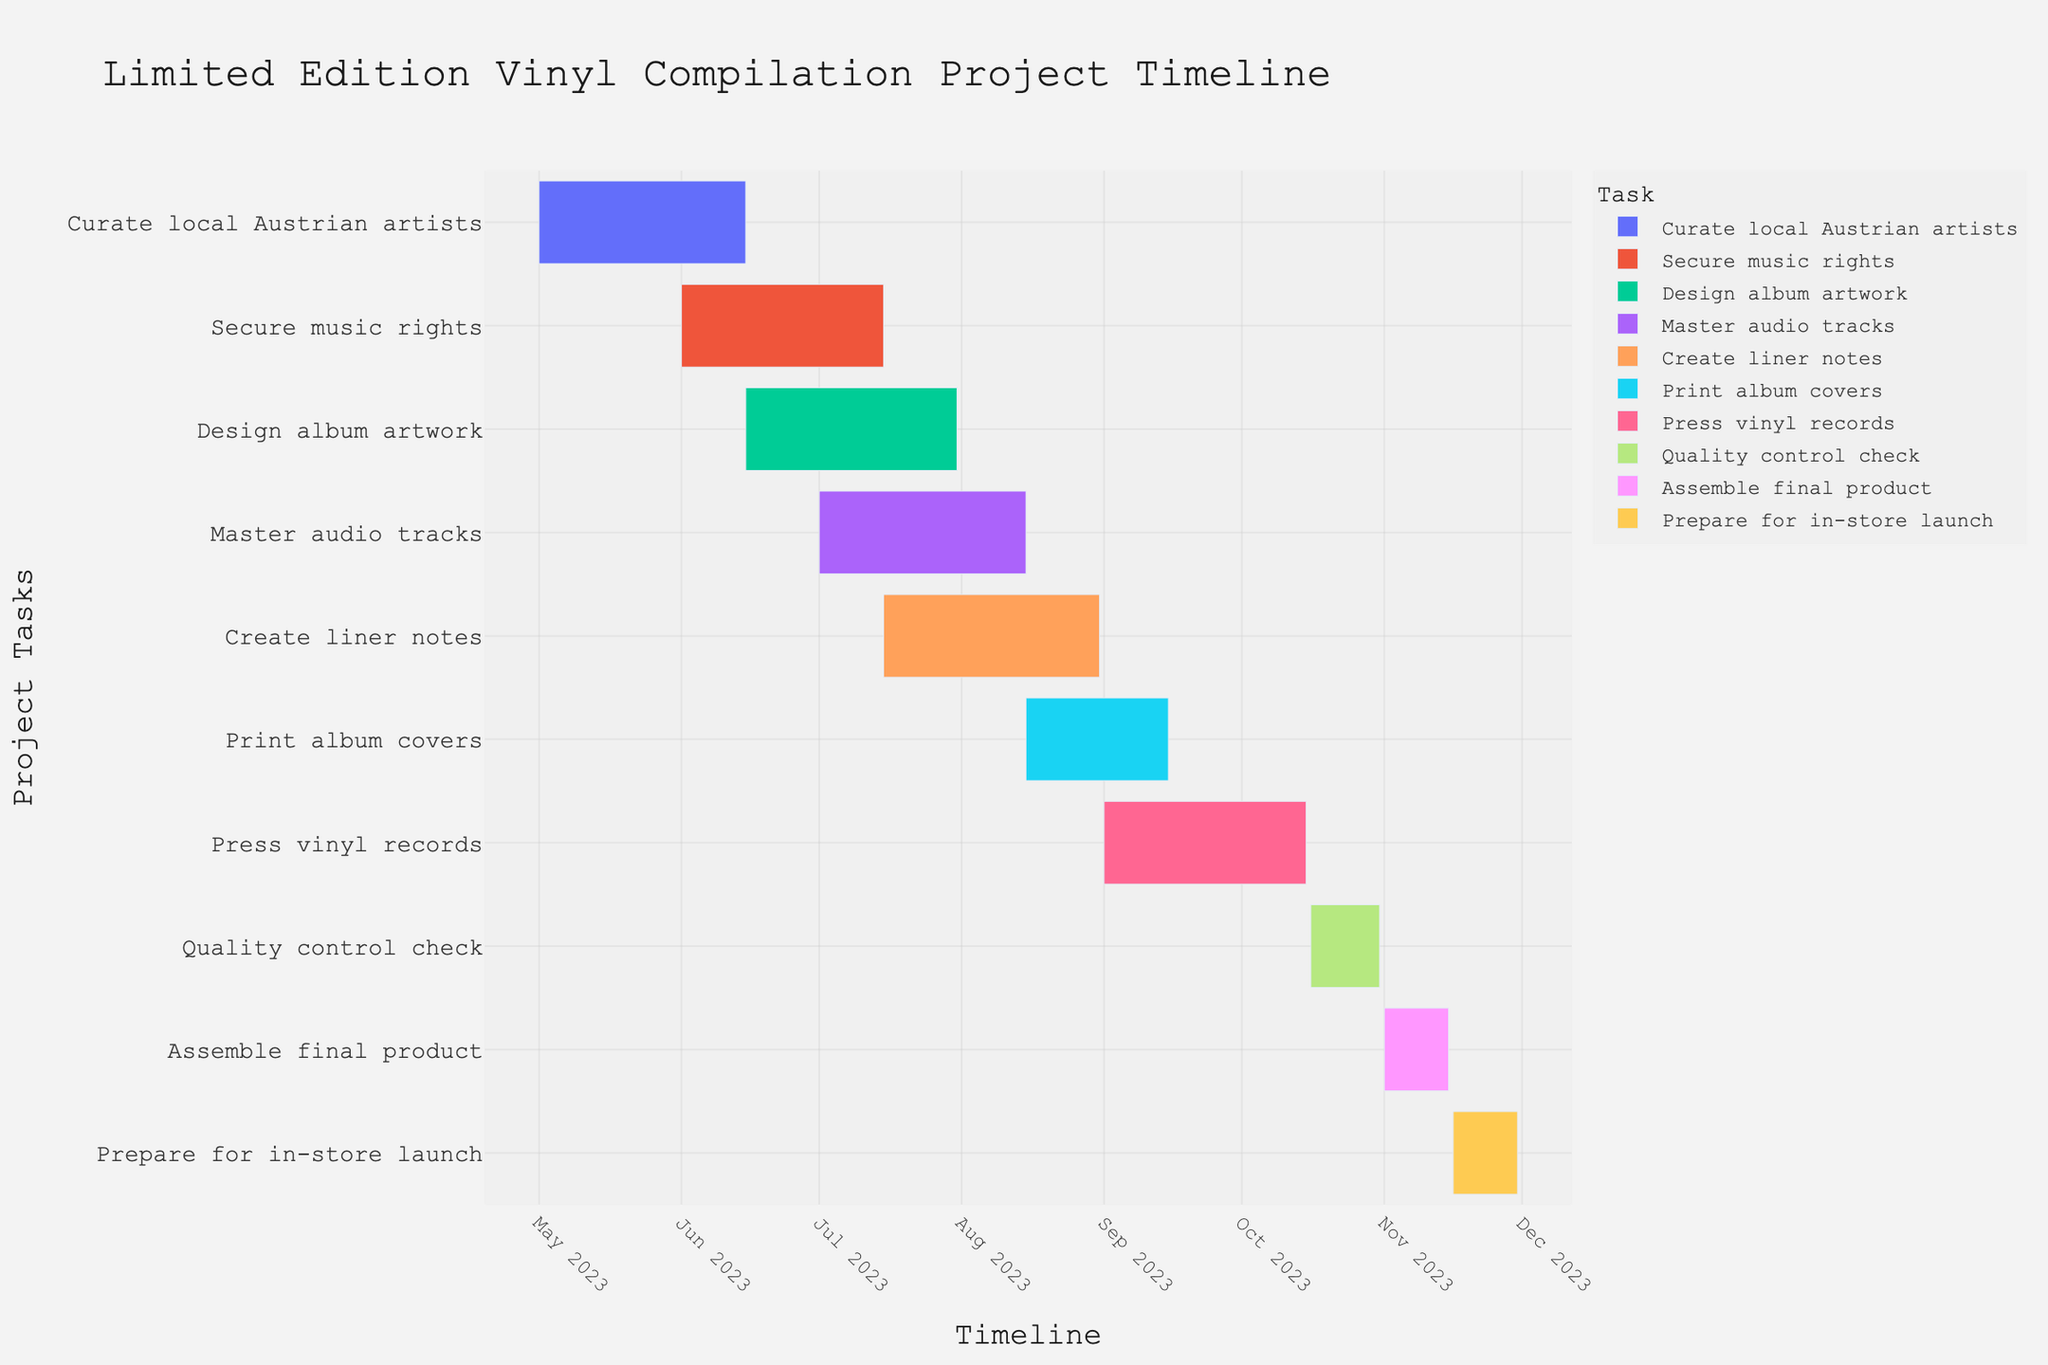What is the title of the Gantt Chart? The title is typically placed at the top of the chart to provide a summary of what the figure represents. By looking at the area on top, you notice the title.
Answer: "Limited Edition Vinyl Compilation Project Timeline" Which task starts the latest? This can be determined by looking at the horizontal bars and finding the one that starts furthest to the right on the timeline. The "Prepare for in-store launch" task starts the latest on November 16, 2023.
Answer: "Prepare for in-store launch" How long is the "Print album covers" task? First, identify the starting and ending dates of the "Print album covers" task from the chart. Then, calculate the duration based on these dates: it starts on August 15, 2023, and ends on September 15, 2023. Therefore, it spans one month.
Answer: 1 month Which task has the longest duration? Scan through the chart to see which horizontal bar extends for the longest distance. "Secure music rights" spans from June 1, 2023, to July 15, 2023, which is approximately 1.5 months. By examining further, "Create liner notes" spans from July 15, 2023, to August 31, 2023, which is approximately also 1.5 months.
Answer: "Secure music rights" and "Create liner notes" What tasks overlap with the "Design album artwork" task? Look at the "Design album artwork" task's timeline and see which other tasks share overlapping start and end dates. The tasks "Secure music rights," and "Master audio tracks" overlap with the "Design album artwork" task.
Answer: "Secure music rights," "Master audio tracks" How many tasks are planned for November? Look at the timeline section for November and count the number of horizontal bars starting or continuing through this month. "Assemble final product" and "Prepare for in-store launch" are the two tasks that are planned.
Answer: 2 What is the interval between the end of "Quality control check" and the start of "Assemble final product"? Identify the end date of "Quality control check" and the start date of "Assemble final product". The end date of "Quality control check" is October 31, 2023, and the start date of "Assemble final product" is November 1, 2023.
Answer: 1 day Which tasks are completed by the end of August? Tasks that end on or before August 31, 2023, include "Curate local Austrian artists," "Secure music rights," "Design album artwork," "Master audio tracks," and "Create liner notes."
Answer: "Curate local Austrian artists," "Secure music rights," "Design album artwork," "Master audio tracks," "Create liner notes" 